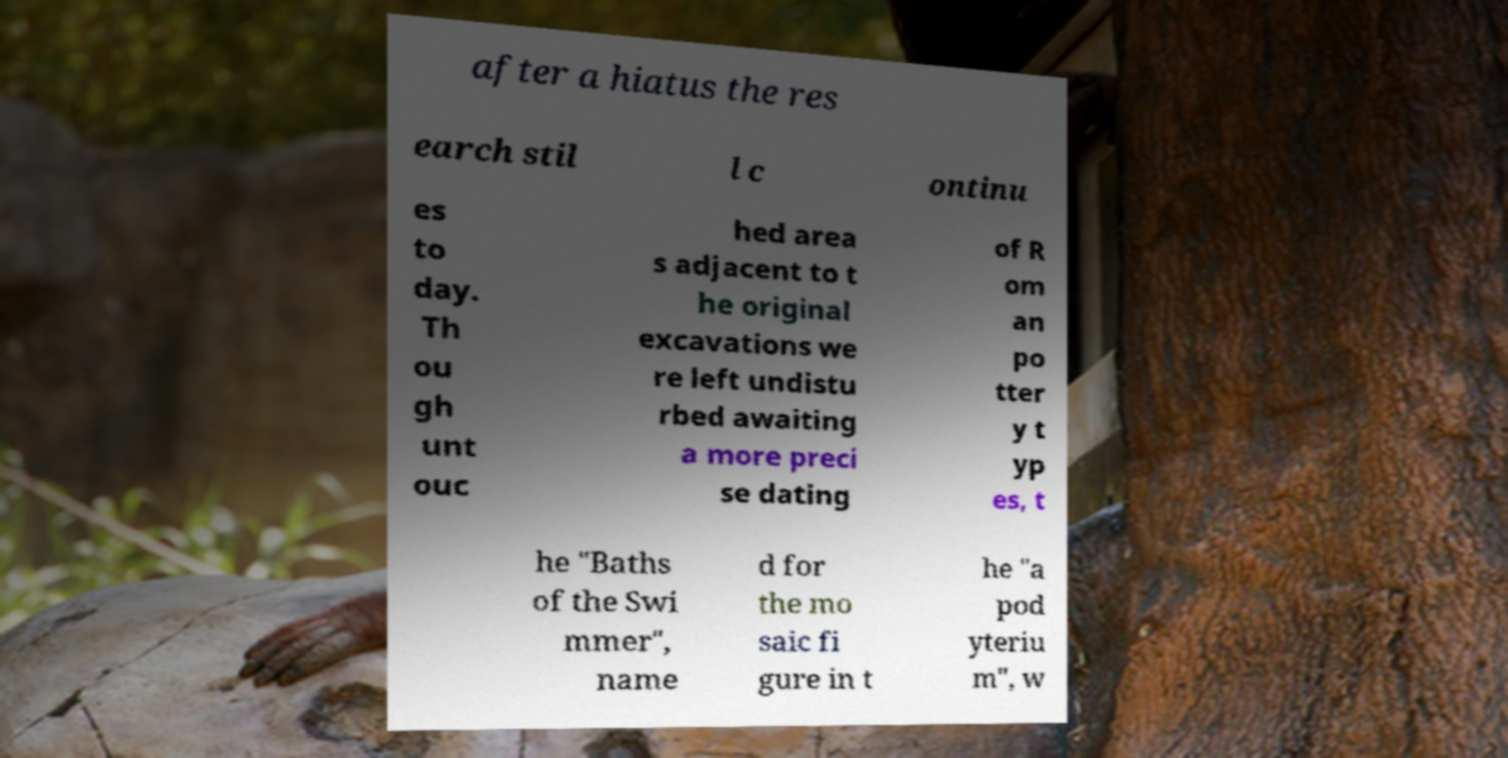Could you assist in decoding the text presented in this image and type it out clearly? after a hiatus the res earch stil l c ontinu es to day. Th ou gh unt ouc hed area s adjacent to t he original excavations we re left undistu rbed awaiting a more preci se dating of R om an po tter y t yp es, t he "Baths of the Swi mmer", name d for the mo saic fi gure in t he "a pod yteriu m", w 